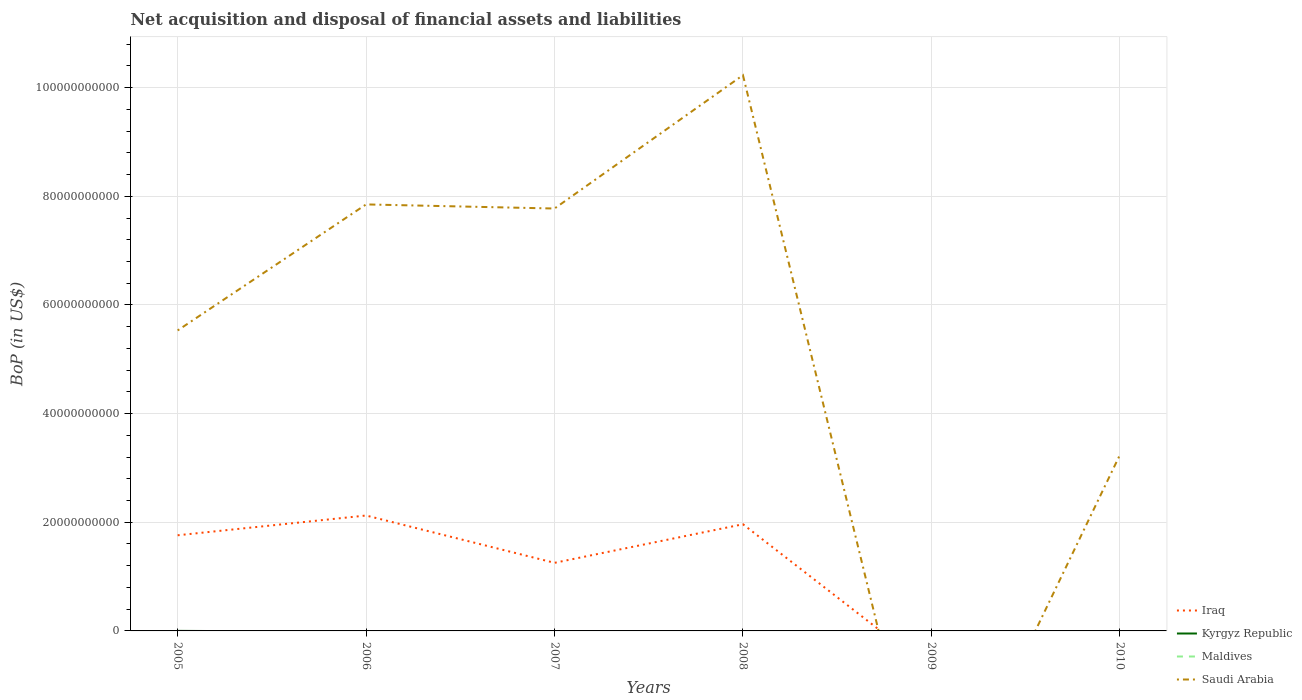What is the difference between the highest and the second highest Balance of Payments in Saudi Arabia?
Give a very brief answer. 1.02e+11. Is the Balance of Payments in Iraq strictly greater than the Balance of Payments in Saudi Arabia over the years?
Your response must be concise. No. How many lines are there?
Keep it short and to the point. 3. How many years are there in the graph?
Make the answer very short. 6. Does the graph contain any zero values?
Make the answer very short. Yes. Does the graph contain grids?
Offer a terse response. Yes. How many legend labels are there?
Keep it short and to the point. 4. What is the title of the graph?
Provide a succinct answer. Net acquisition and disposal of financial assets and liabilities. What is the label or title of the Y-axis?
Your answer should be very brief. BoP (in US$). What is the BoP (in US$) in Iraq in 2005?
Give a very brief answer. 1.76e+1. What is the BoP (in US$) in Kyrgyz Republic in 2005?
Provide a short and direct response. 7.59e+06. What is the BoP (in US$) of Saudi Arabia in 2005?
Provide a short and direct response. 5.53e+1. What is the BoP (in US$) in Iraq in 2006?
Provide a short and direct response. 2.12e+1. What is the BoP (in US$) of Kyrgyz Republic in 2006?
Make the answer very short. 0. What is the BoP (in US$) of Maldives in 2006?
Make the answer very short. 0. What is the BoP (in US$) in Saudi Arabia in 2006?
Your answer should be compact. 7.85e+1. What is the BoP (in US$) of Iraq in 2007?
Make the answer very short. 1.25e+1. What is the BoP (in US$) in Maldives in 2007?
Keep it short and to the point. 0. What is the BoP (in US$) in Saudi Arabia in 2007?
Offer a terse response. 7.78e+1. What is the BoP (in US$) of Iraq in 2008?
Offer a terse response. 1.96e+1. What is the BoP (in US$) of Maldives in 2008?
Provide a short and direct response. 0. What is the BoP (in US$) of Saudi Arabia in 2008?
Offer a terse response. 1.02e+11. What is the BoP (in US$) of Saudi Arabia in 2010?
Your answer should be very brief. 3.24e+1. Across all years, what is the maximum BoP (in US$) in Iraq?
Make the answer very short. 2.12e+1. Across all years, what is the maximum BoP (in US$) of Kyrgyz Republic?
Keep it short and to the point. 7.59e+06. Across all years, what is the maximum BoP (in US$) of Saudi Arabia?
Ensure brevity in your answer.  1.02e+11. Across all years, what is the minimum BoP (in US$) in Iraq?
Keep it short and to the point. 0. Across all years, what is the minimum BoP (in US$) in Saudi Arabia?
Provide a succinct answer. 0. What is the total BoP (in US$) of Iraq in the graph?
Offer a terse response. 7.10e+1. What is the total BoP (in US$) of Kyrgyz Republic in the graph?
Make the answer very short. 7.59e+06. What is the total BoP (in US$) of Maldives in the graph?
Provide a succinct answer. 0. What is the total BoP (in US$) of Saudi Arabia in the graph?
Give a very brief answer. 3.46e+11. What is the difference between the BoP (in US$) in Iraq in 2005 and that in 2006?
Offer a very short reply. -3.64e+09. What is the difference between the BoP (in US$) of Saudi Arabia in 2005 and that in 2006?
Provide a short and direct response. -2.32e+1. What is the difference between the BoP (in US$) in Iraq in 2005 and that in 2007?
Your answer should be very brief. 5.07e+09. What is the difference between the BoP (in US$) of Saudi Arabia in 2005 and that in 2007?
Provide a succinct answer. -2.24e+1. What is the difference between the BoP (in US$) in Iraq in 2005 and that in 2008?
Provide a short and direct response. -2.03e+09. What is the difference between the BoP (in US$) of Saudi Arabia in 2005 and that in 2008?
Offer a terse response. -4.70e+1. What is the difference between the BoP (in US$) in Saudi Arabia in 2005 and that in 2010?
Provide a short and direct response. 2.29e+1. What is the difference between the BoP (in US$) in Iraq in 2006 and that in 2007?
Provide a succinct answer. 8.71e+09. What is the difference between the BoP (in US$) in Saudi Arabia in 2006 and that in 2007?
Your answer should be very brief. 7.55e+08. What is the difference between the BoP (in US$) in Iraq in 2006 and that in 2008?
Offer a very short reply. 1.61e+09. What is the difference between the BoP (in US$) in Saudi Arabia in 2006 and that in 2008?
Make the answer very short. -2.38e+1. What is the difference between the BoP (in US$) of Saudi Arabia in 2006 and that in 2010?
Keep it short and to the point. 4.61e+1. What is the difference between the BoP (in US$) of Iraq in 2007 and that in 2008?
Your answer should be very brief. -7.10e+09. What is the difference between the BoP (in US$) of Saudi Arabia in 2007 and that in 2008?
Your response must be concise. -2.45e+1. What is the difference between the BoP (in US$) of Saudi Arabia in 2007 and that in 2010?
Provide a succinct answer. 4.54e+1. What is the difference between the BoP (in US$) in Saudi Arabia in 2008 and that in 2010?
Make the answer very short. 6.99e+1. What is the difference between the BoP (in US$) of Iraq in 2005 and the BoP (in US$) of Saudi Arabia in 2006?
Offer a terse response. -6.09e+1. What is the difference between the BoP (in US$) in Kyrgyz Republic in 2005 and the BoP (in US$) in Saudi Arabia in 2006?
Provide a succinct answer. -7.85e+1. What is the difference between the BoP (in US$) in Iraq in 2005 and the BoP (in US$) in Saudi Arabia in 2007?
Provide a short and direct response. -6.01e+1. What is the difference between the BoP (in US$) in Kyrgyz Republic in 2005 and the BoP (in US$) in Saudi Arabia in 2007?
Make the answer very short. -7.77e+1. What is the difference between the BoP (in US$) of Iraq in 2005 and the BoP (in US$) of Saudi Arabia in 2008?
Offer a terse response. -8.47e+1. What is the difference between the BoP (in US$) of Kyrgyz Republic in 2005 and the BoP (in US$) of Saudi Arabia in 2008?
Offer a terse response. -1.02e+11. What is the difference between the BoP (in US$) of Iraq in 2005 and the BoP (in US$) of Saudi Arabia in 2010?
Provide a succinct answer. -1.48e+1. What is the difference between the BoP (in US$) in Kyrgyz Republic in 2005 and the BoP (in US$) in Saudi Arabia in 2010?
Ensure brevity in your answer.  -3.24e+1. What is the difference between the BoP (in US$) of Iraq in 2006 and the BoP (in US$) of Saudi Arabia in 2007?
Make the answer very short. -5.65e+1. What is the difference between the BoP (in US$) in Iraq in 2006 and the BoP (in US$) in Saudi Arabia in 2008?
Provide a succinct answer. -8.11e+1. What is the difference between the BoP (in US$) of Iraq in 2006 and the BoP (in US$) of Saudi Arabia in 2010?
Give a very brief answer. -1.11e+1. What is the difference between the BoP (in US$) in Iraq in 2007 and the BoP (in US$) in Saudi Arabia in 2008?
Ensure brevity in your answer.  -8.98e+1. What is the difference between the BoP (in US$) of Iraq in 2007 and the BoP (in US$) of Saudi Arabia in 2010?
Ensure brevity in your answer.  -1.98e+1. What is the difference between the BoP (in US$) of Iraq in 2008 and the BoP (in US$) of Saudi Arabia in 2010?
Offer a very short reply. -1.27e+1. What is the average BoP (in US$) in Iraq per year?
Your response must be concise. 1.18e+1. What is the average BoP (in US$) in Kyrgyz Republic per year?
Offer a very short reply. 1.27e+06. What is the average BoP (in US$) in Maldives per year?
Make the answer very short. 0. What is the average BoP (in US$) in Saudi Arabia per year?
Your response must be concise. 5.77e+1. In the year 2005, what is the difference between the BoP (in US$) of Iraq and BoP (in US$) of Kyrgyz Republic?
Your answer should be very brief. 1.76e+1. In the year 2005, what is the difference between the BoP (in US$) of Iraq and BoP (in US$) of Saudi Arabia?
Offer a terse response. -3.77e+1. In the year 2005, what is the difference between the BoP (in US$) of Kyrgyz Republic and BoP (in US$) of Saudi Arabia?
Make the answer very short. -5.53e+1. In the year 2006, what is the difference between the BoP (in US$) in Iraq and BoP (in US$) in Saudi Arabia?
Your answer should be compact. -5.73e+1. In the year 2007, what is the difference between the BoP (in US$) of Iraq and BoP (in US$) of Saudi Arabia?
Ensure brevity in your answer.  -6.52e+1. In the year 2008, what is the difference between the BoP (in US$) in Iraq and BoP (in US$) in Saudi Arabia?
Make the answer very short. -8.27e+1. What is the ratio of the BoP (in US$) in Iraq in 2005 to that in 2006?
Ensure brevity in your answer.  0.83. What is the ratio of the BoP (in US$) in Saudi Arabia in 2005 to that in 2006?
Offer a very short reply. 0.7. What is the ratio of the BoP (in US$) in Iraq in 2005 to that in 2007?
Provide a short and direct response. 1.4. What is the ratio of the BoP (in US$) of Saudi Arabia in 2005 to that in 2007?
Your answer should be compact. 0.71. What is the ratio of the BoP (in US$) of Iraq in 2005 to that in 2008?
Keep it short and to the point. 0.9. What is the ratio of the BoP (in US$) of Saudi Arabia in 2005 to that in 2008?
Offer a terse response. 0.54. What is the ratio of the BoP (in US$) of Saudi Arabia in 2005 to that in 2010?
Make the answer very short. 1.71. What is the ratio of the BoP (in US$) in Iraq in 2006 to that in 2007?
Your answer should be very brief. 1.69. What is the ratio of the BoP (in US$) in Saudi Arabia in 2006 to that in 2007?
Offer a very short reply. 1.01. What is the ratio of the BoP (in US$) in Iraq in 2006 to that in 2008?
Make the answer very short. 1.08. What is the ratio of the BoP (in US$) in Saudi Arabia in 2006 to that in 2008?
Provide a succinct answer. 0.77. What is the ratio of the BoP (in US$) of Saudi Arabia in 2006 to that in 2010?
Keep it short and to the point. 2.43. What is the ratio of the BoP (in US$) of Iraq in 2007 to that in 2008?
Offer a terse response. 0.64. What is the ratio of the BoP (in US$) of Saudi Arabia in 2007 to that in 2008?
Ensure brevity in your answer.  0.76. What is the ratio of the BoP (in US$) of Saudi Arabia in 2007 to that in 2010?
Ensure brevity in your answer.  2.4. What is the ratio of the BoP (in US$) in Saudi Arabia in 2008 to that in 2010?
Your answer should be compact. 3.16. What is the difference between the highest and the second highest BoP (in US$) in Iraq?
Provide a succinct answer. 1.61e+09. What is the difference between the highest and the second highest BoP (in US$) in Saudi Arabia?
Provide a short and direct response. 2.38e+1. What is the difference between the highest and the lowest BoP (in US$) in Iraq?
Give a very brief answer. 2.12e+1. What is the difference between the highest and the lowest BoP (in US$) in Kyrgyz Republic?
Your answer should be compact. 7.59e+06. What is the difference between the highest and the lowest BoP (in US$) in Saudi Arabia?
Ensure brevity in your answer.  1.02e+11. 